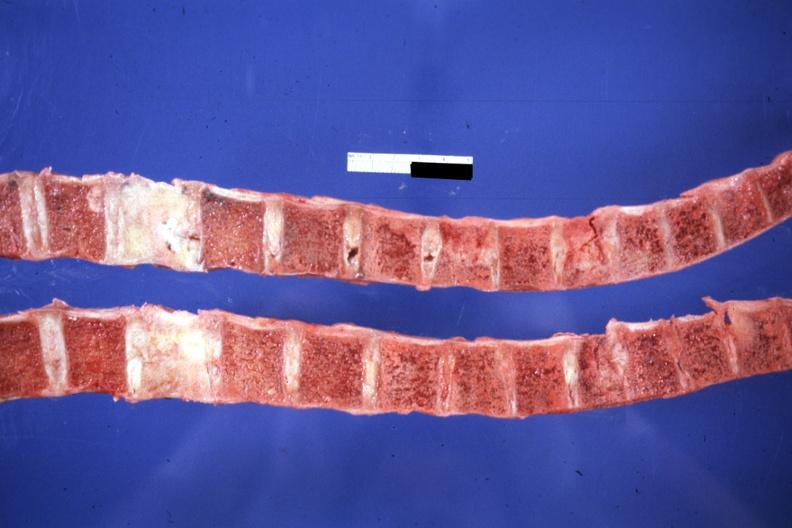what do not know history but probably breast lesion?
Answer the question using a single word or phrase. Saggital section typical 